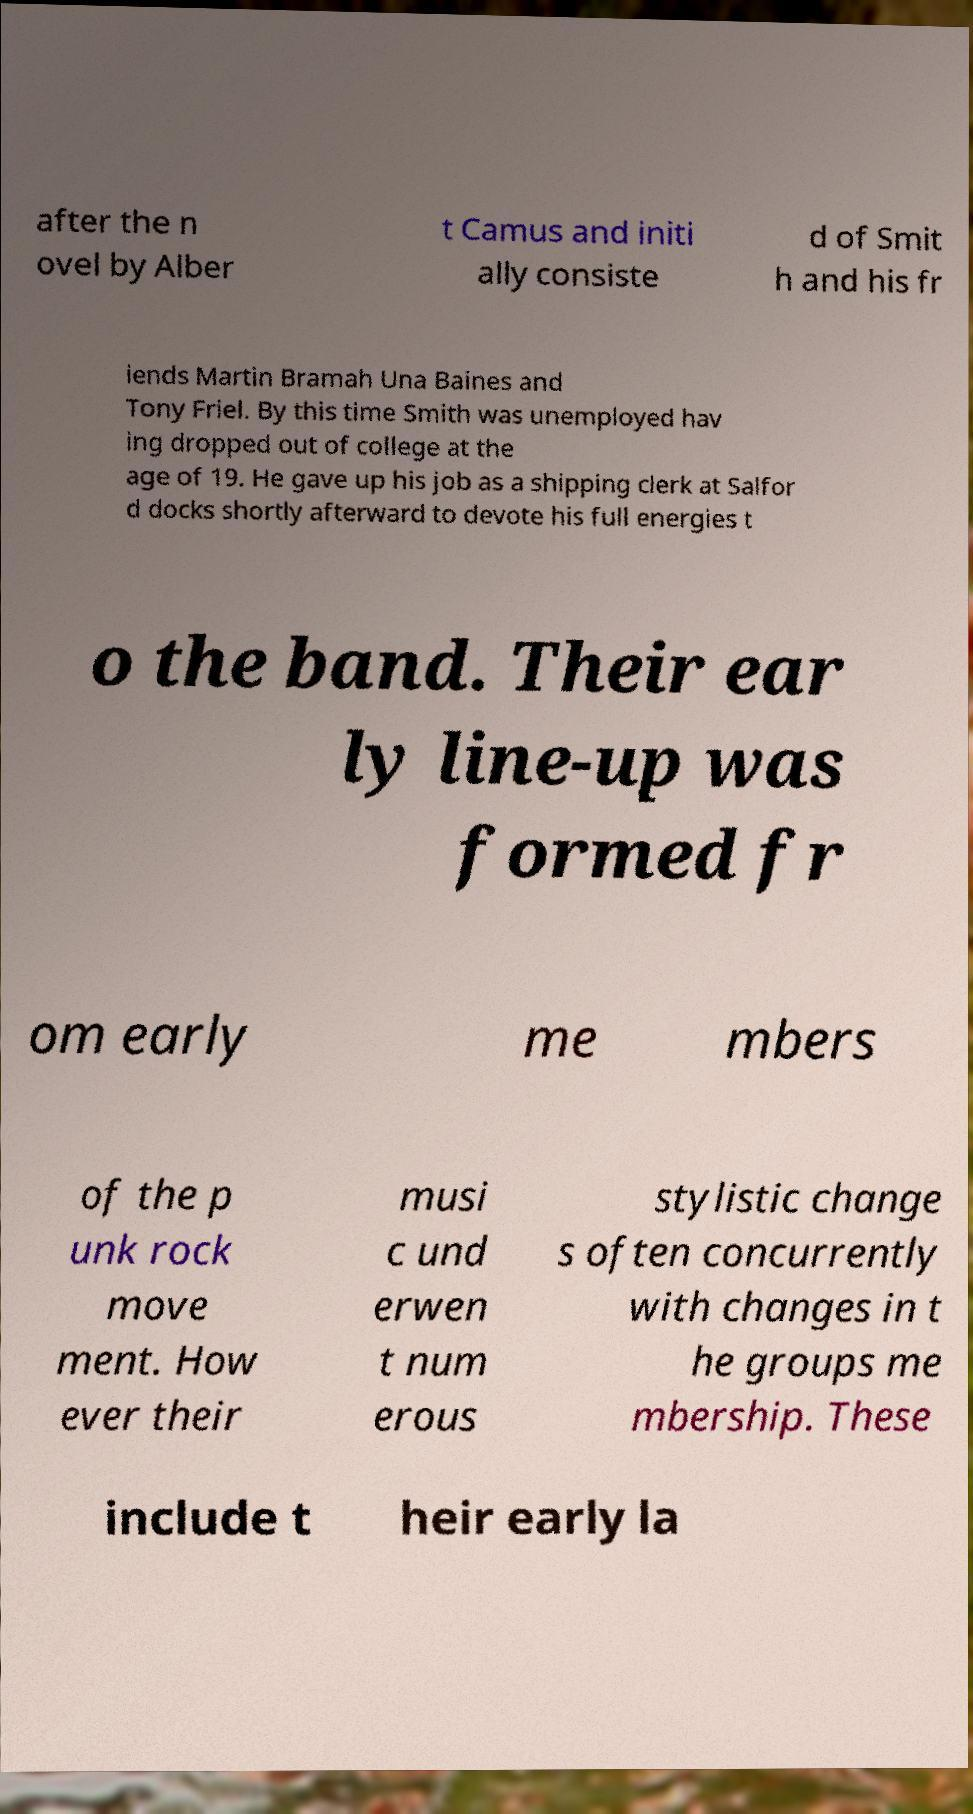Please identify and transcribe the text found in this image. after the n ovel by Alber t Camus and initi ally consiste d of Smit h and his fr iends Martin Bramah Una Baines and Tony Friel. By this time Smith was unemployed hav ing dropped out of college at the age of 19. He gave up his job as a shipping clerk at Salfor d docks shortly afterward to devote his full energies t o the band. Their ear ly line-up was formed fr om early me mbers of the p unk rock move ment. How ever their musi c und erwen t num erous stylistic change s often concurrently with changes in t he groups me mbership. These include t heir early la 